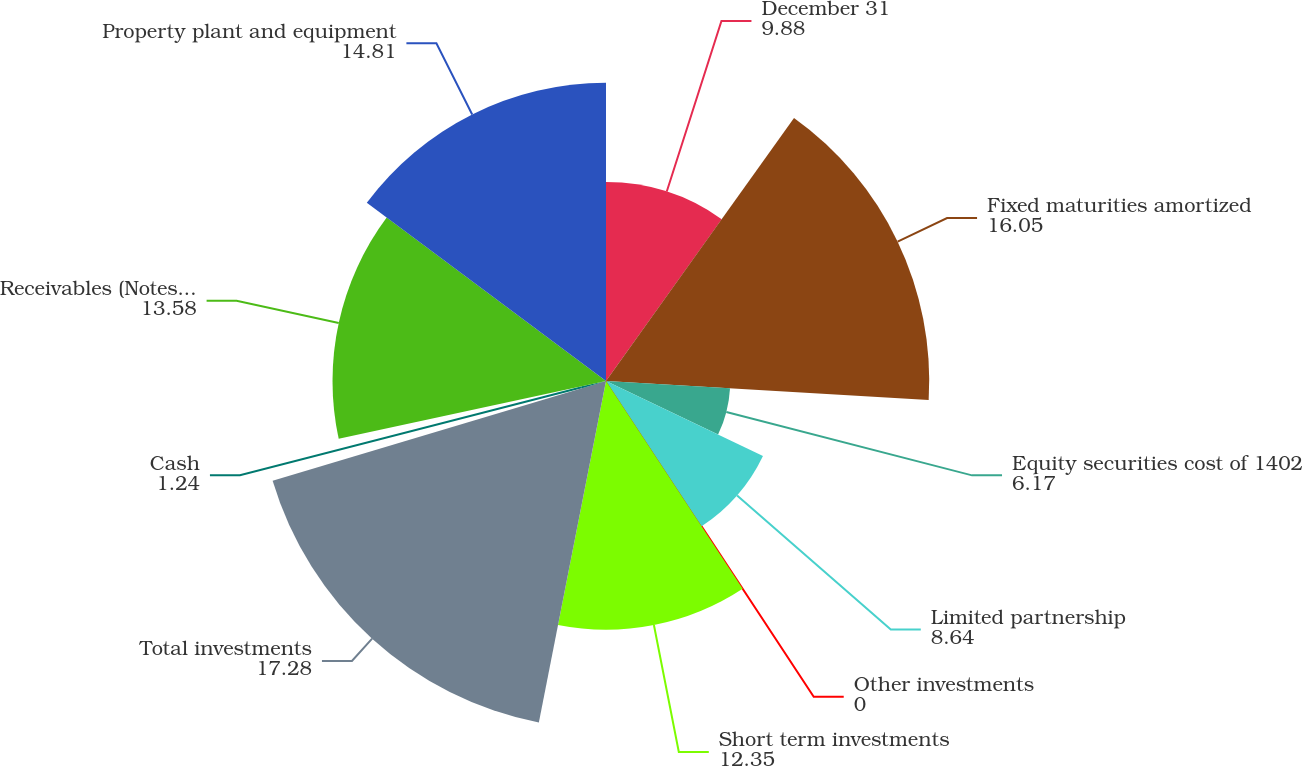Convert chart. <chart><loc_0><loc_0><loc_500><loc_500><pie_chart><fcel>December 31<fcel>Fixed maturities amortized<fcel>Equity securities cost of 1402<fcel>Limited partnership<fcel>Other investments<fcel>Short term investments<fcel>Total investments<fcel>Cash<fcel>Receivables (Notes 1 and 7)<fcel>Property plant and equipment<nl><fcel>9.88%<fcel>16.05%<fcel>6.17%<fcel>8.64%<fcel>0.0%<fcel>12.35%<fcel>17.28%<fcel>1.24%<fcel>13.58%<fcel>14.81%<nl></chart> 